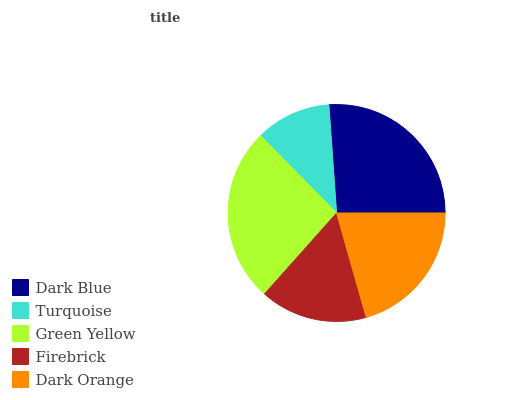Is Turquoise the minimum?
Answer yes or no. Yes. Is Dark Blue the maximum?
Answer yes or no. Yes. Is Green Yellow the minimum?
Answer yes or no. No. Is Green Yellow the maximum?
Answer yes or no. No. Is Green Yellow greater than Turquoise?
Answer yes or no. Yes. Is Turquoise less than Green Yellow?
Answer yes or no. Yes. Is Turquoise greater than Green Yellow?
Answer yes or no. No. Is Green Yellow less than Turquoise?
Answer yes or no. No. Is Dark Orange the high median?
Answer yes or no. Yes. Is Dark Orange the low median?
Answer yes or no. Yes. Is Turquoise the high median?
Answer yes or no. No. Is Dark Blue the low median?
Answer yes or no. No. 